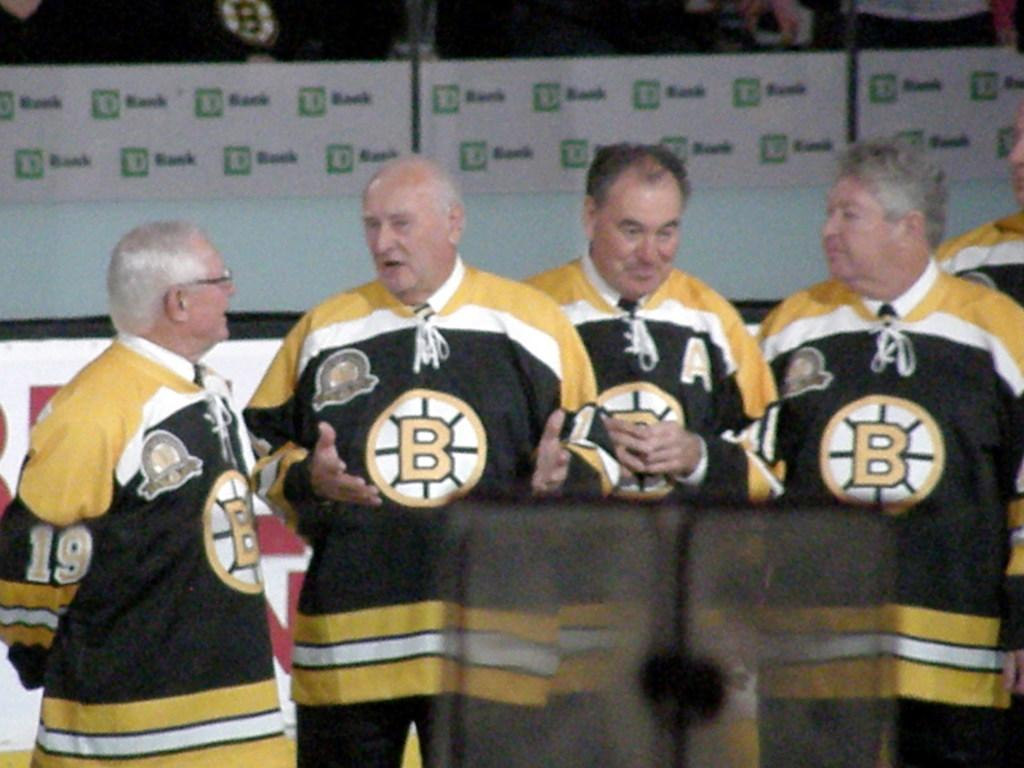<image>
Create a compact narrative representing the image presented. Several people are wearing jerseys with the letter B on the front. 